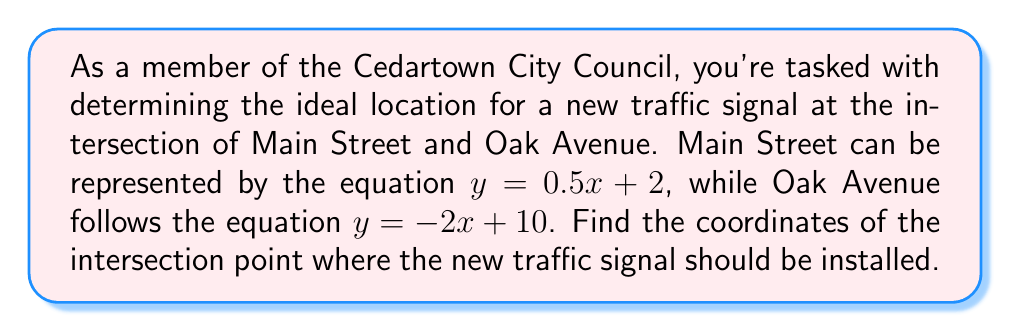What is the answer to this math problem? Let's approach this step-by-step:

1) We have two linear equations:
   Main Street: $y = 0.5x + 2$
   Oak Avenue: $y = -2x + 10$

2) To find the intersection point, we need to solve these equations simultaneously. At the intersection point, the x and y coordinates will be the same for both equations.

3) Let's set the right sides of the equations equal to each other:
   $0.5x + 2 = -2x + 10$

4) Now, let's solve for x:
   $0.5x + 2x = 10 - 2$
   $2.5x = 8$
   $x = 8 / 2.5 = 3.2$

5) Now that we know the x-coordinate, we can substitute it into either of the original equations to find y. Let's use Main Street's equation:
   $y = 0.5(3.2) + 2$
   $y = 1.6 + 2 = 3.6$

6) Therefore, the intersection point is (3.2, 3.6).

[asy]
import geometry;

size(200);
xaxis("x", -1, 6, arrow=Arrow);
yaxis("y", -1, 6, arrow=Arrow);

real f(real x) {return 0.5x + 2;}
real g(real x) {return -2x + 10;}

draw(graph(f, -1, 6), blue, "Main Street");
draw(graph(g, -1, 6), red, "Oak Avenue");

dot((3.2, 3.6), green);
label("(3.2, 3.6)", (3.2, 3.6), NE);
[/asy]
Answer: (3.2, 3.6) 